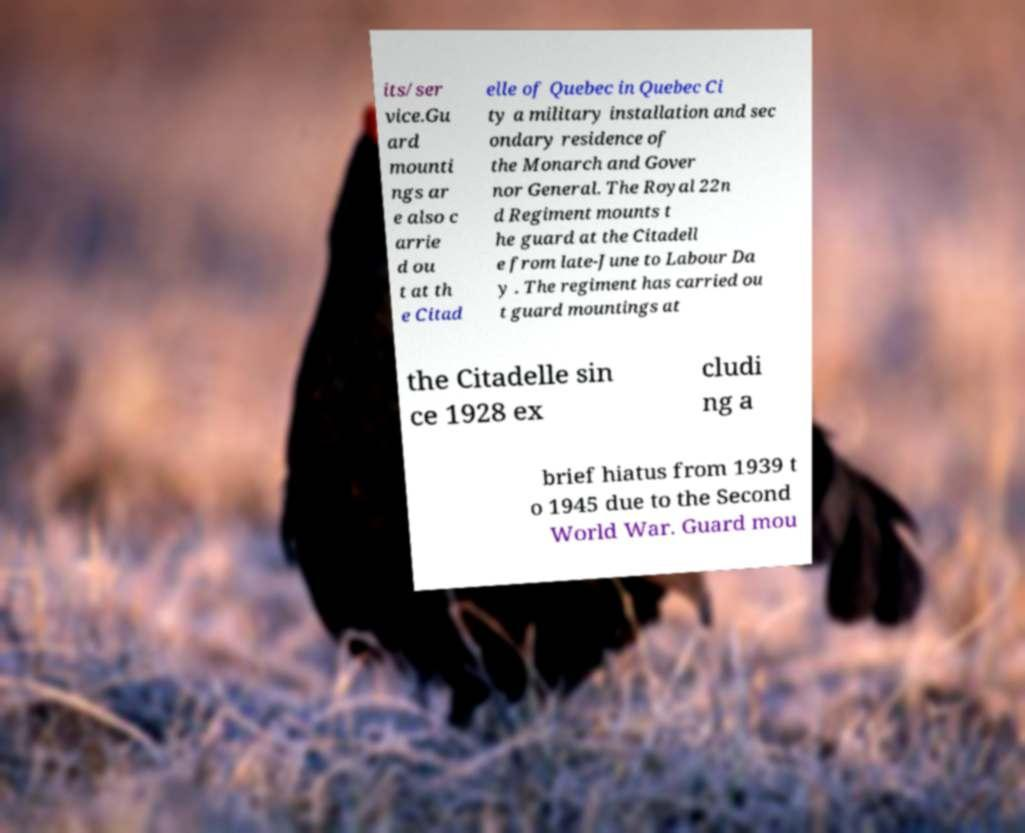Can you accurately transcribe the text from the provided image for me? its/ser vice.Gu ard mounti ngs ar e also c arrie d ou t at th e Citad elle of Quebec in Quebec Ci ty a military installation and sec ondary residence of the Monarch and Gover nor General. The Royal 22n d Regiment mounts t he guard at the Citadell e from late-June to Labour Da y . The regiment has carried ou t guard mountings at the Citadelle sin ce 1928 ex cludi ng a brief hiatus from 1939 t o 1945 due to the Second World War. Guard mou 